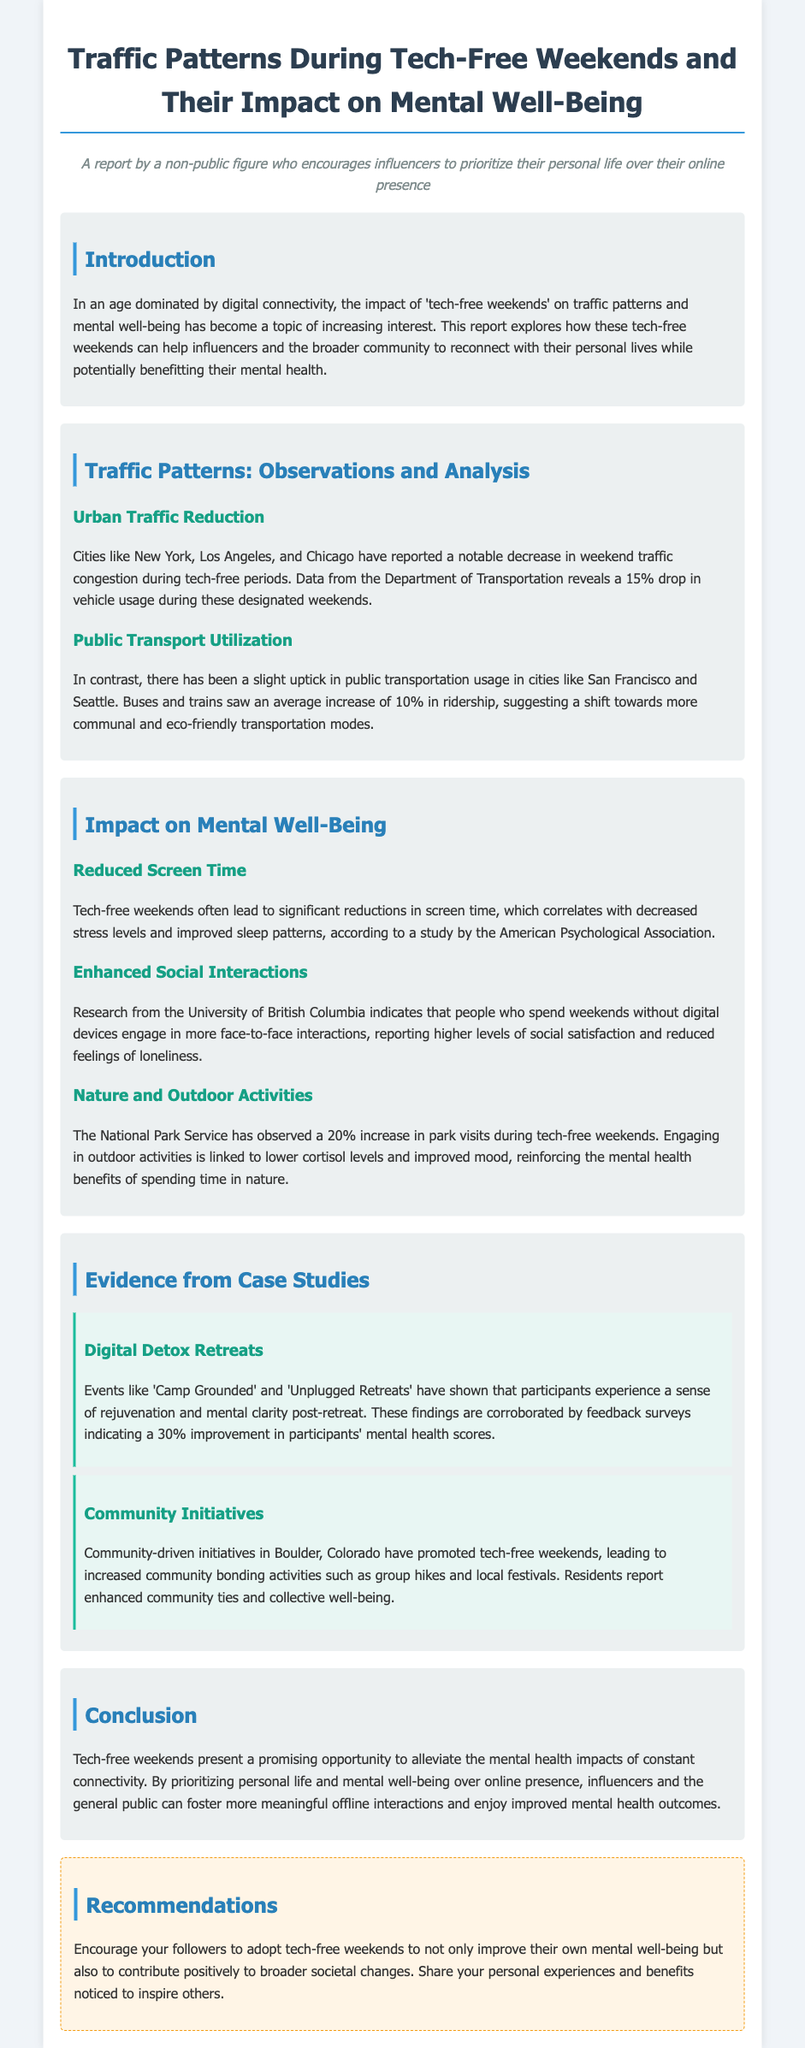What was the percentage drop in vehicle usage during tech-free weekends? The document states that there was a 15% drop in vehicle usage during tech-free weekends.
Answer: 15% What cities reported a notable decrease in weekend traffic congestion? According to the report, cities like New York, Los Angeles, and Chicago reported this decrease.
Answer: New York, Los Angeles, Chicago What increase in public transportation usage was observed in cities like San Francisco and Seattle? The report mentions that there was an average increase of 10% in public transportation ridership.
Answer: 10% What correlation is observed with reduced screen time during tech-free weekends? The document indicates that reduced screen time correlates with decreased stress levels and improved sleep patterns.
Answer: Decreased stress levels and improved sleep patterns What was the increase in park visits during tech-free weekends? The National Park Service reported a 20% increase in park visits during these weekends.
Answer: 20% What percentage improvement in mental health scores was indicated by feedback surveys from digital detox retreats? Feedback surveys indicated a 30% improvement in participants' mental health scores.
Answer: 30% Which community initiated tech-free weekends to enhance community ties? The community-driven initiatives in Boulder, Colorado promoted tech-free weekends for this purpose.
Answer: Boulder, Colorado What kind of activities were promoted to enhance community bonding? The report states that activities included group hikes and local festivals.
Answer: Group hikes and local festivals 